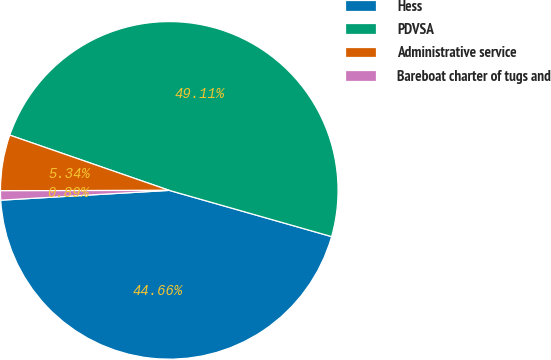Convert chart to OTSL. <chart><loc_0><loc_0><loc_500><loc_500><pie_chart><fcel>Hess<fcel>PDVSA<fcel>Administrative service<fcel>Bareboat charter of tugs and<nl><fcel>44.66%<fcel>49.11%<fcel>5.34%<fcel>0.89%<nl></chart> 